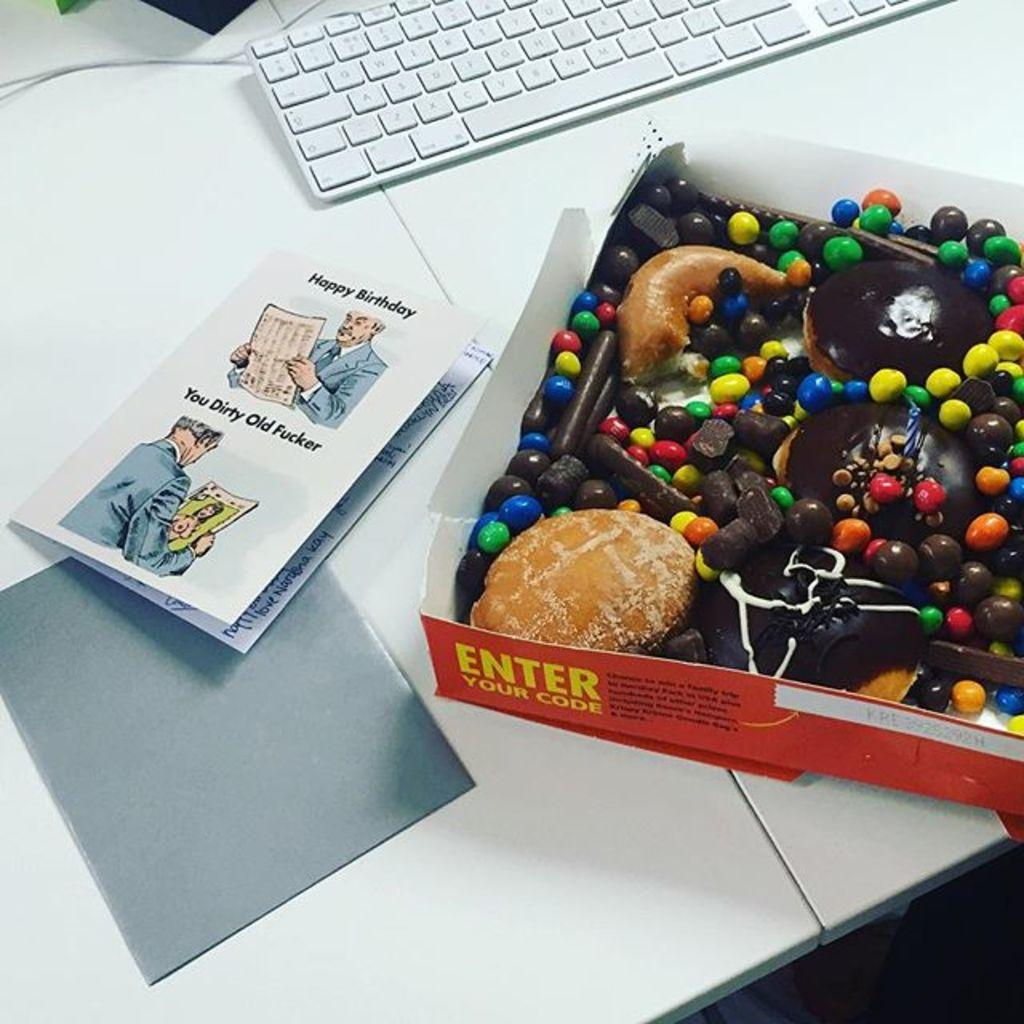<image>
Present a compact description of the photo's key features. A happy birthday card next to a box of candy with a half eaten donut in it 